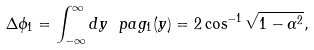<formula> <loc_0><loc_0><loc_500><loc_500>\Delta \phi _ { 1 } = \int _ { - \infty } ^ { \infty } d y \ p a g _ { 1 } ( y ) = 2 \cos ^ { - 1 } \sqrt { 1 - \alpha ^ { 2 } } ,</formula> 